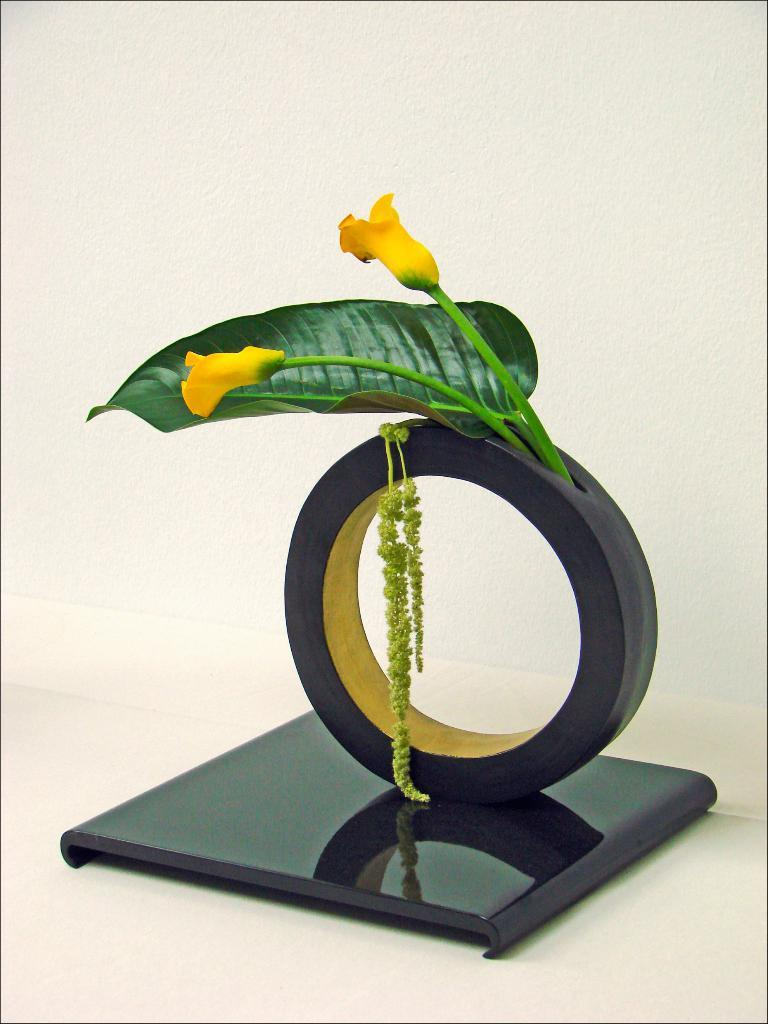What is the main object in the picture? There is a memento in the picture. What decorations are on the memento? The memento has flowers and a leaf on it. What is the color of the surface the memento is placed on? The memento is on a white surface. Is there a bag containing party supplies in the image? There is no bag or party supplies present in the image. When was the birth of the person who created the memento? The provided facts do not mention any information about the person who created the memento or their birth. 